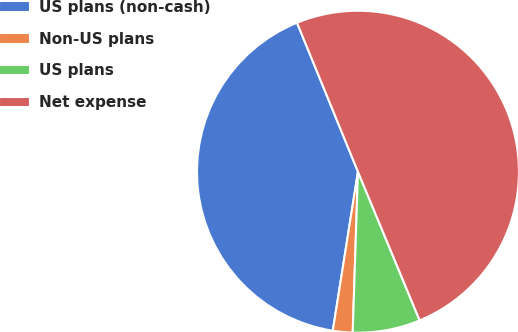<chart> <loc_0><loc_0><loc_500><loc_500><pie_chart><fcel>US plans (non-cash)<fcel>Non-US plans<fcel>US plans<fcel>Net expense<nl><fcel>41.32%<fcel>1.98%<fcel>6.78%<fcel>49.92%<nl></chart> 